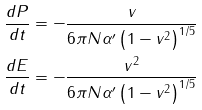Convert formula to latex. <formula><loc_0><loc_0><loc_500><loc_500>\frac { d P } { d t } & = - \frac { v } { 6 \pi N \alpha ^ { \prime } \left ( 1 - v ^ { 2 } \right ) ^ { 1 / 5 } } \\ \frac { d E } { d t } & = - \frac { v ^ { 2 } } { 6 \pi N \alpha ^ { \prime } \left ( 1 - v ^ { 2 } \right ) ^ { 1 / 5 } }</formula> 